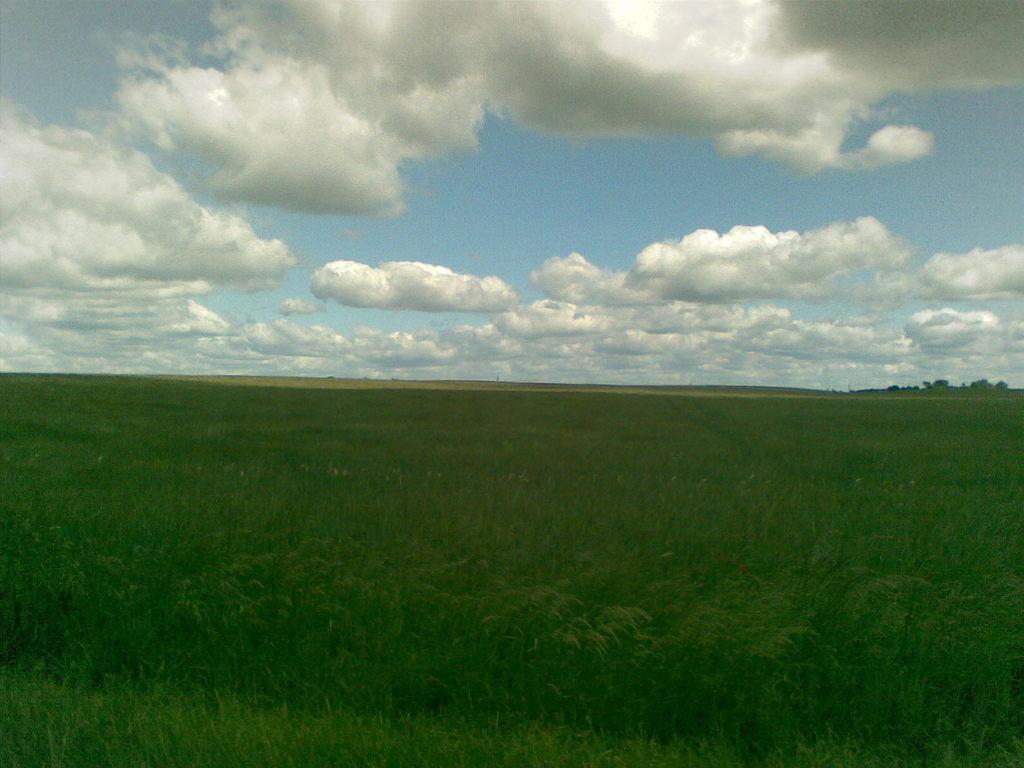Describe this image in one or two sentences. In the image in the center we can see the sky,clouds,trees and grass. 